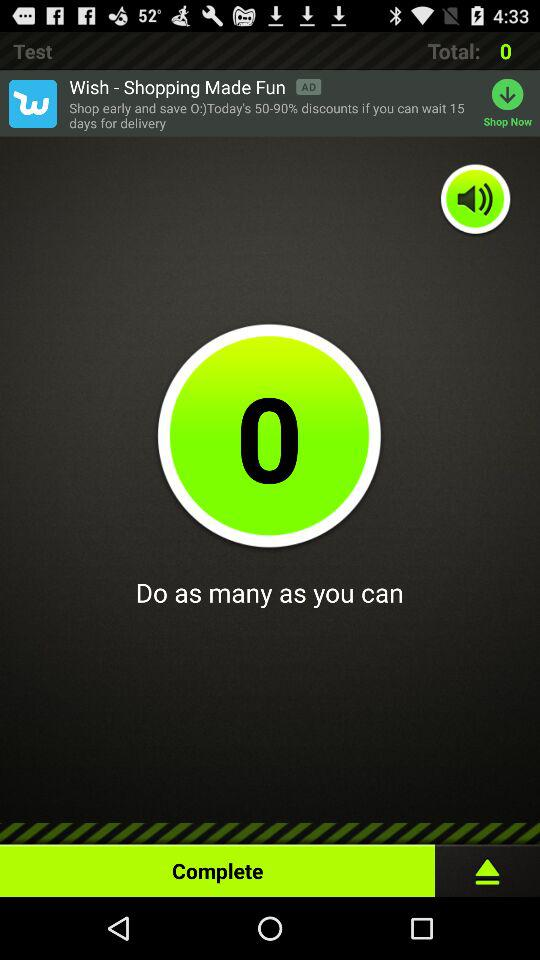What is the total count? The total count is 0. 